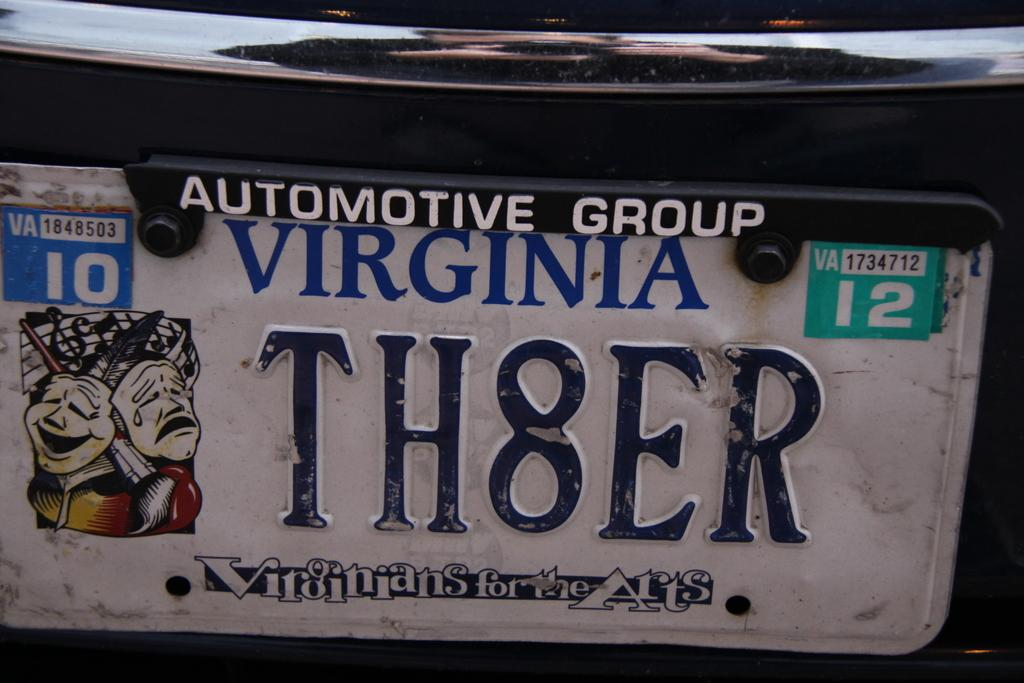What can be found on a vehicle that is visible in the image? The image contains a number plate of a vehicle. What type of information is displayed on the number plate? The number on the number plate is a combination of alphabets and numbers. What key is used to unlock the vehicle in the image? There is no key visible in the image, and we cannot determine which key would unlock the vehicle. 